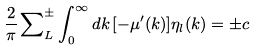Convert formula to latex. <formula><loc_0><loc_0><loc_500><loc_500>\frac { 2 } { \pi } \sum _ { L } ^ { \pm } \nolimits \int _ { 0 } ^ { \infty } d k \, [ - \mu ^ { \prime } ( k ) ] \eta _ { l } ( k ) = \pm c</formula> 